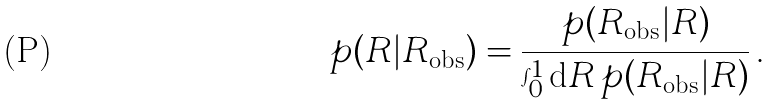<formula> <loc_0><loc_0><loc_500><loc_500>p ( R | R _ { \text {obs} } ) = \frac { p ( R _ { \text {obs} } | R ) } { \int _ { 0 } ^ { 1 } \text {d} R \, p ( R _ { \text {obs} } | R ) } \, .</formula> 